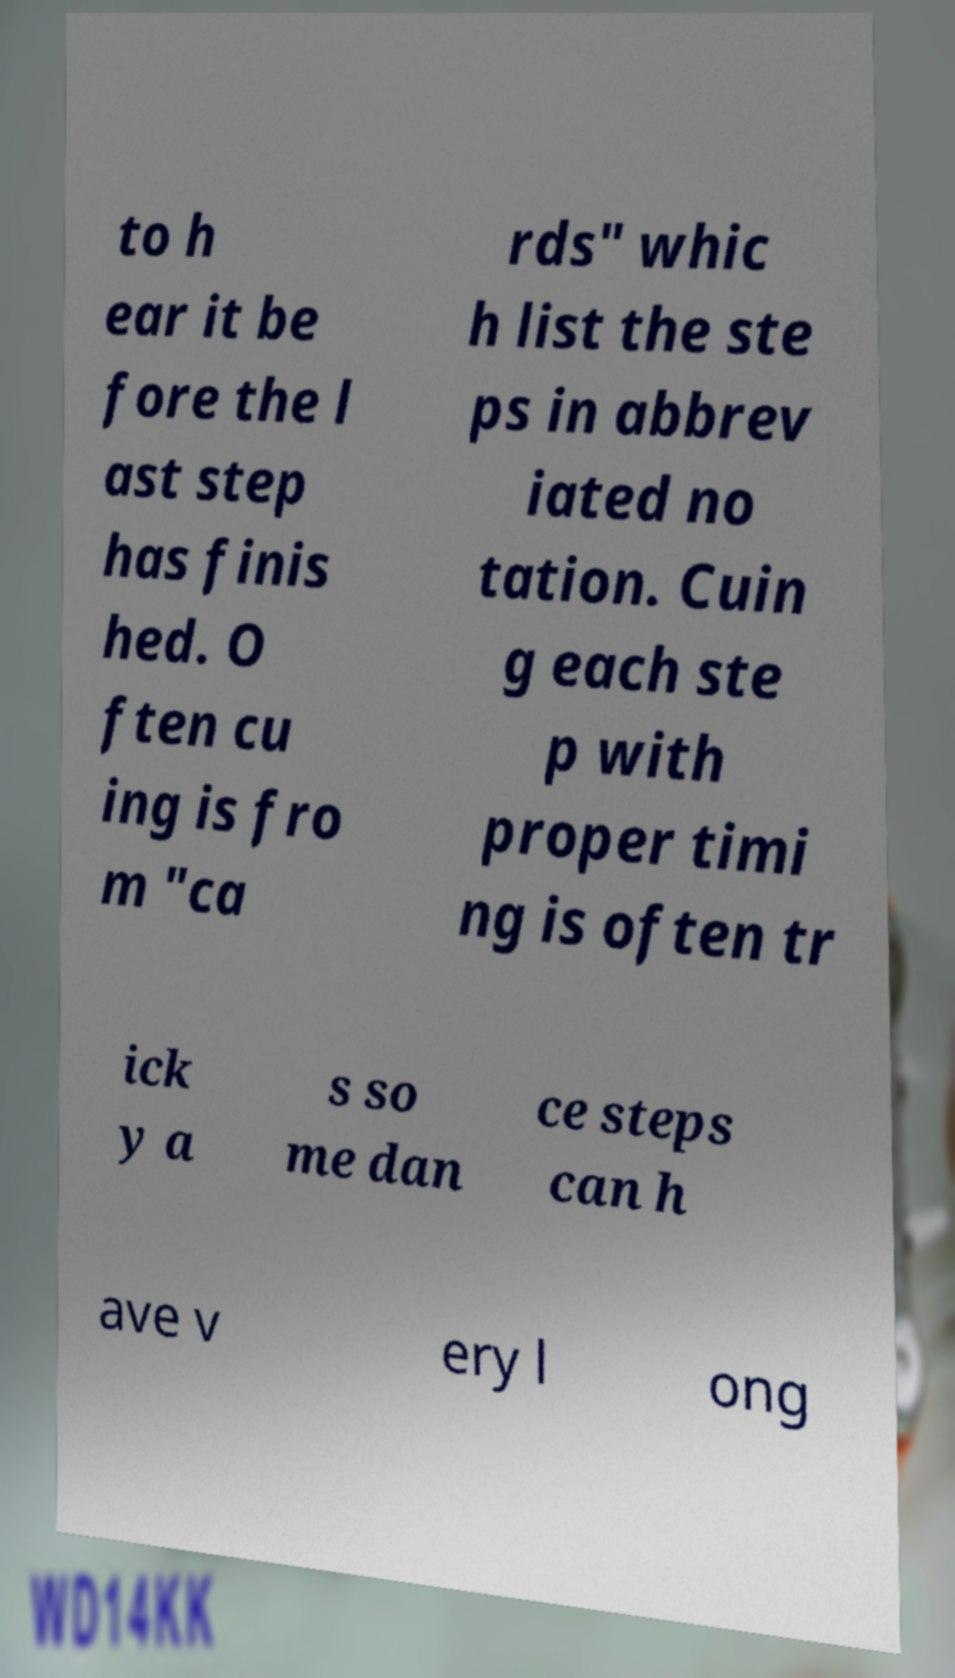There's text embedded in this image that I need extracted. Can you transcribe it verbatim? to h ear it be fore the l ast step has finis hed. O ften cu ing is fro m "ca rds" whic h list the ste ps in abbrev iated no tation. Cuin g each ste p with proper timi ng is often tr ick y a s so me dan ce steps can h ave v ery l ong 